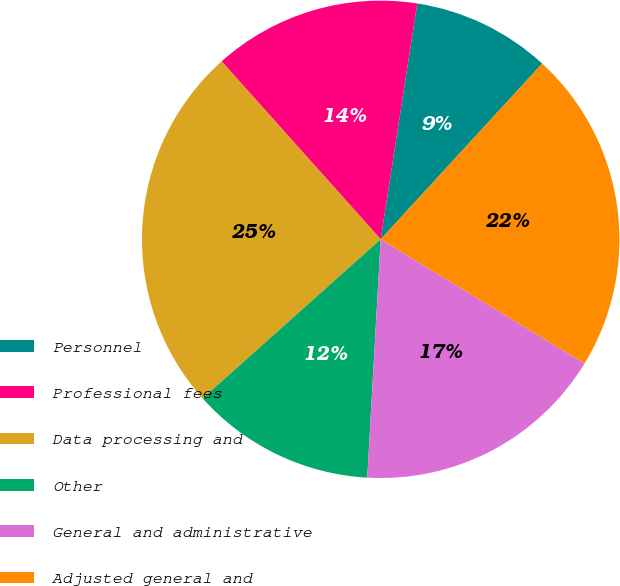<chart> <loc_0><loc_0><loc_500><loc_500><pie_chart><fcel>Personnel<fcel>Professional fees<fcel>Data processing and<fcel>Other<fcel>General and administrative<fcel>Adjusted general and<nl><fcel>9.38%<fcel>14.06%<fcel>25.0%<fcel>12.5%<fcel>17.19%<fcel>21.88%<nl></chart> 